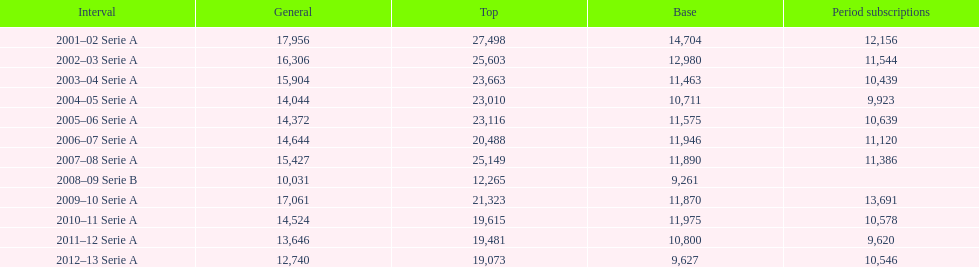How many seasons had average attendance of at least 15,000 at the stadio ennio tardini? 5. 